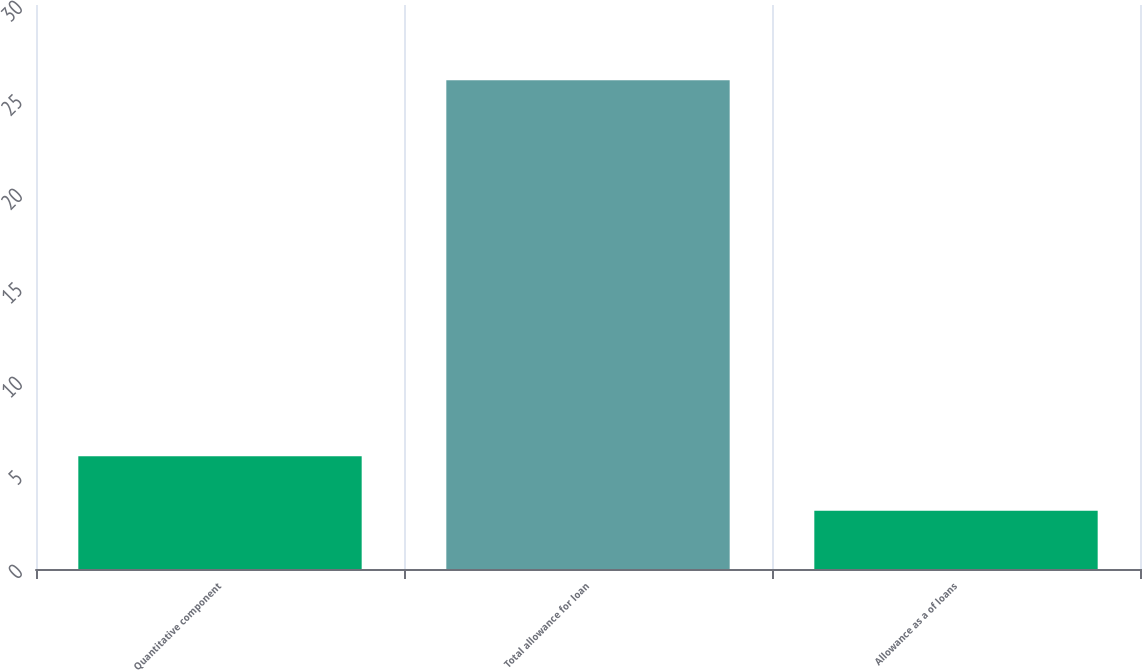Convert chart. <chart><loc_0><loc_0><loc_500><loc_500><bar_chart><fcel>Quantitative component<fcel>Total allowance for loan<fcel>Allowance as a of loans<nl><fcel>6<fcel>26<fcel>3.1<nl></chart> 